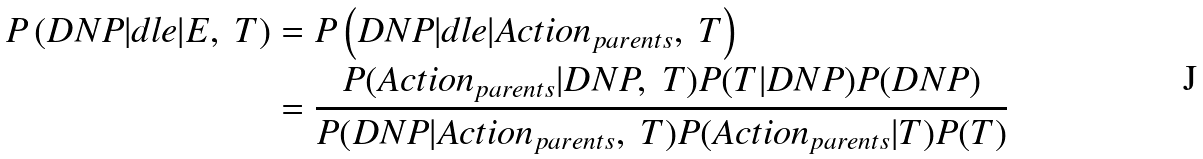Convert formula to latex. <formula><loc_0><loc_0><loc_500><loc_500>P \left ( D N P | d l e | E , \ T \right ) & = P \left ( D N P | d l e | A c t i o n _ { p a r e n t s } , \ T \right ) \\ & = \frac { P ( A c t i o n _ { p a r e n t s } | D N P , \ T ) P ( T | D N P ) P ( D N P ) } { P ( D N P | A c t i o n _ { p a r e n t s } , \ T ) P ( A c t i o n _ { p a r e n t s } | T ) P ( T ) }</formula> 